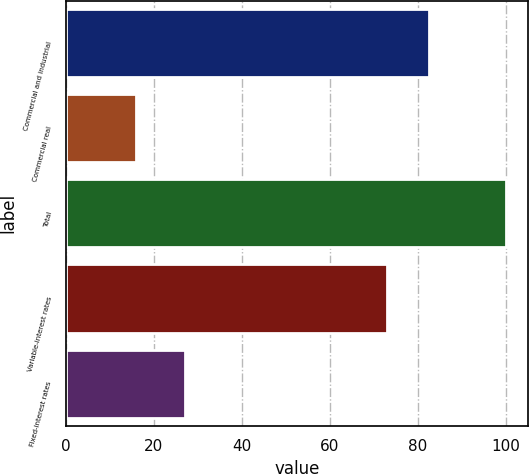Convert chart. <chart><loc_0><loc_0><loc_500><loc_500><bar_chart><fcel>Commercial and industrial<fcel>Commercial real<fcel>Total<fcel>Variable-interest rates<fcel>Fixed-interest rates<nl><fcel>82.6<fcel>16<fcel>100<fcel>73<fcel>27<nl></chart> 